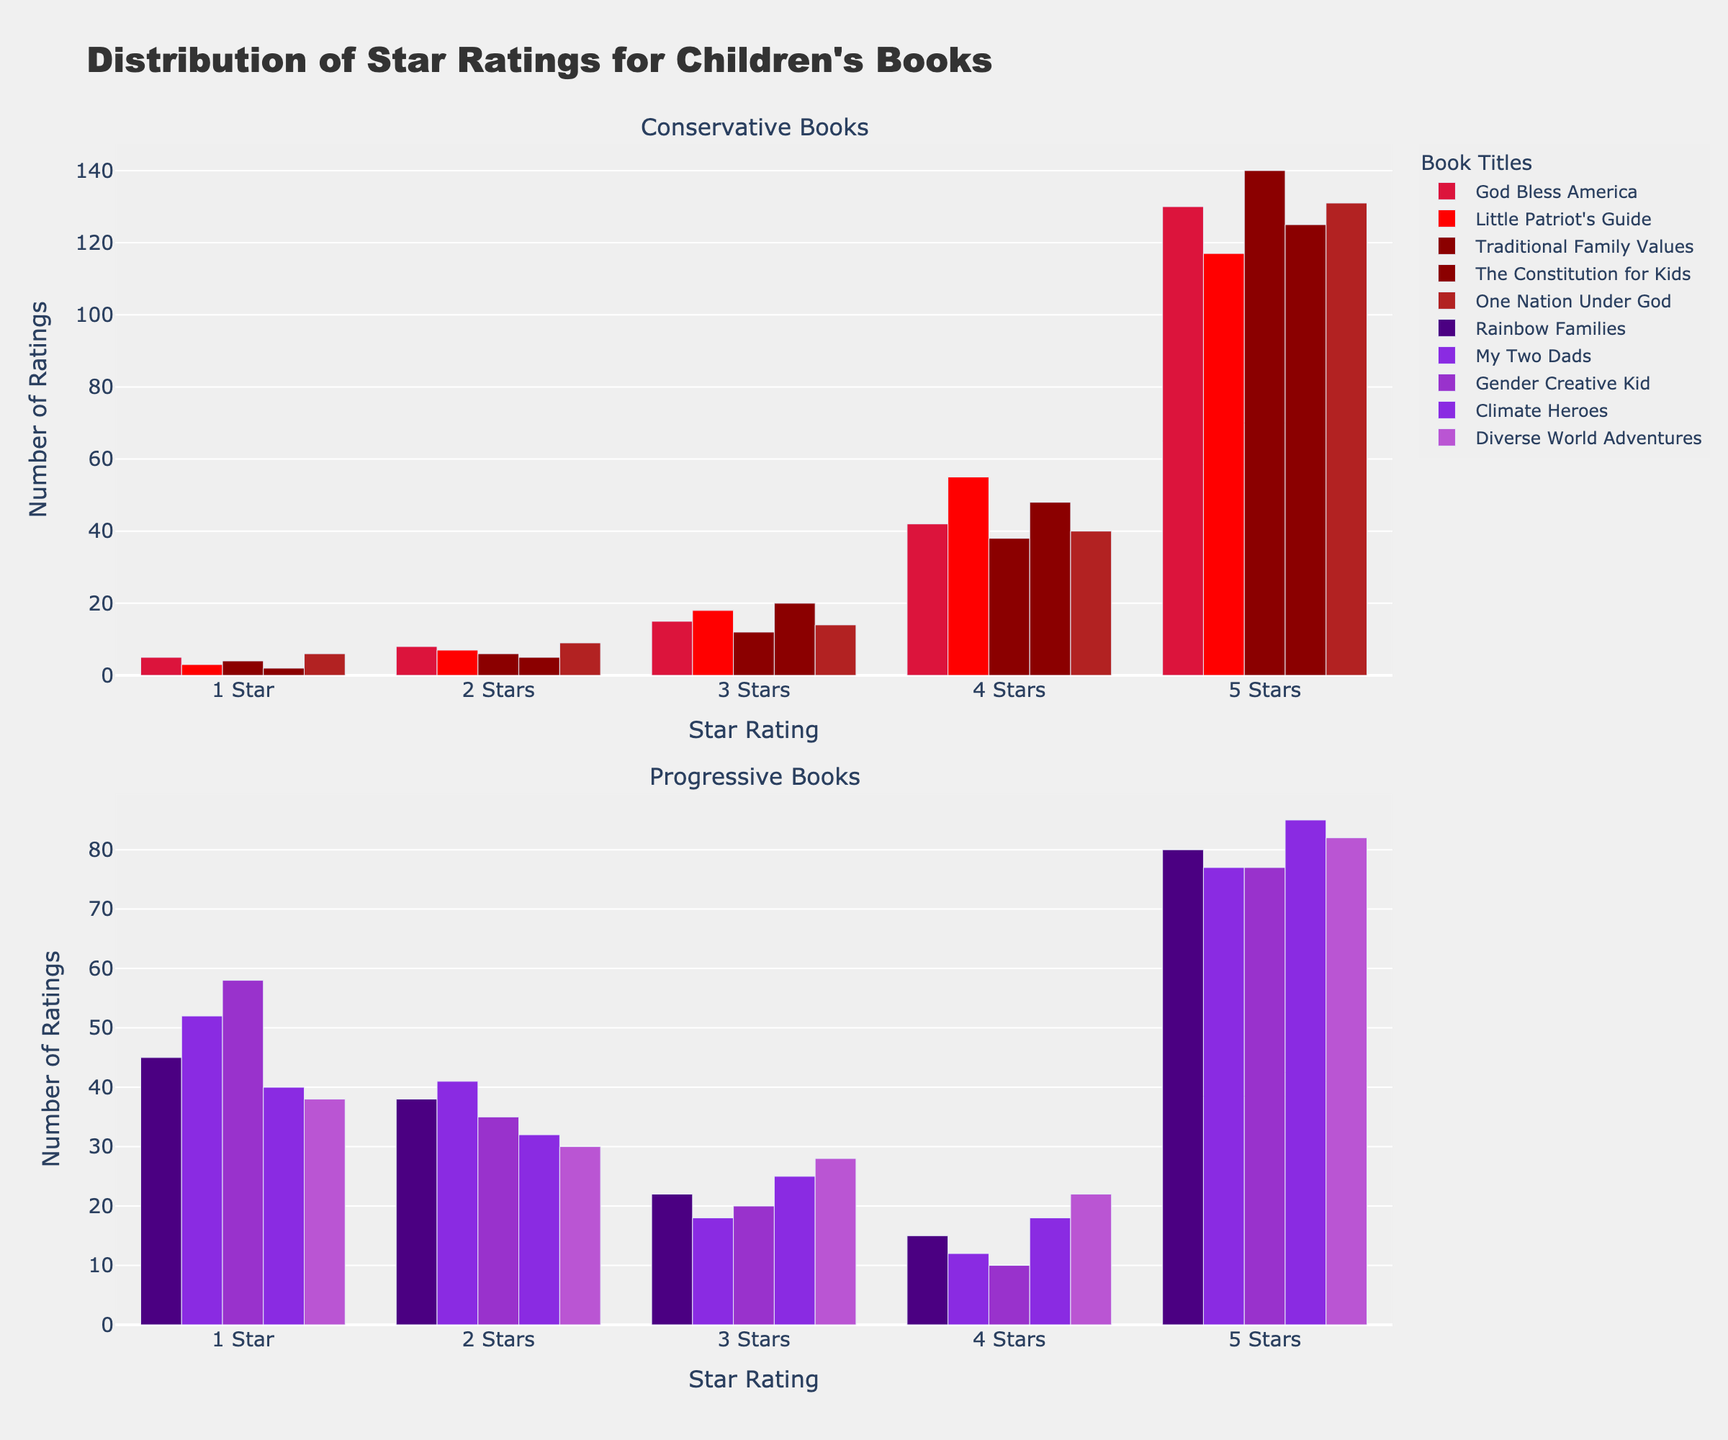What is the title of the figure? The title is displayed at the top of the figure and it reads "Distribution of Star Ratings for Children's Books."
Answer: Distribution of Star Ratings for Children's Books Which star rating has the highest number of ratings for conservative books overall? By inspecting the heights of the bars in the first subplot for conservative books, the 5-star rating has the highest number of ratings.
Answer: 5-star What patterns do you observe in the distribution of star ratings between conservative and progressive books? Conservative books show higher ratings predominantly with more 5-star ratings, while progressive books have more 1-star and 2-star ratings resembling a distribution skewed towards lower ratings.
Answer: Conservative: high ratings, Progressive: low ratings How does the number of 1-star ratings for "The Constitution for Kids" compare to "My Two Dads"? Compare the height of the 1-star bar for "The Constitution for Kids" in the conservative section with the 1-star bar for "My Two Dads" in the progressive section; "The Constitution for Kids" has 2 ratings, while "My Two Dads" has 52 ratings.
Answer: "The Constitution for Kids": 2, "My Two Dads": 52 Which book among the progressive category has a rating distribution closest to "God Bless America"? Look for a progressive book with a lower spread of ratings similar to "God Bless America"; "Climate Heroes" appears to have a similar spread of higher 5-star ratings although reversed for low ratings.
Answer: "Climate Heroes" What is the total number of ratings for "Traditional Family Values"? Sum the individual ratings for 1-star, 2-stars, 3-stars, 4-stars, and 5-stars in the "Traditional Family Values" bar (4+6+12+38+140).
Answer: 200 What visual characteristic differentiates conservative books from progressive books in the subplots? The bars representing conservative books are shaded in shades of red, while those for progressive books are in shades of purple.
Answer: Color difference: red for conservative, purple for progressive Which book has the highest number of 5-star ratings in the progressive section, and how many does it have? Check the highest bars in the 5-star ratings in the progressive section, "Climate Heroes" has the highest with 85 ratings.
Answer: "Climate Heroes", 85 How does the distribution of star ratings for "Rainbow Families" differ from "One Nation Under God"? "Rainbow Families" has more 1-star and fewer 5-star ratings, while "One Nation Under God" has fewer 1-star and significantly more 5-star ratings, indicating a more favorable reception.
Answer: "Rainbow Families": more 1-star, fewer 5-star; "One Nation Under God": fewer 1-star, more 5-star 